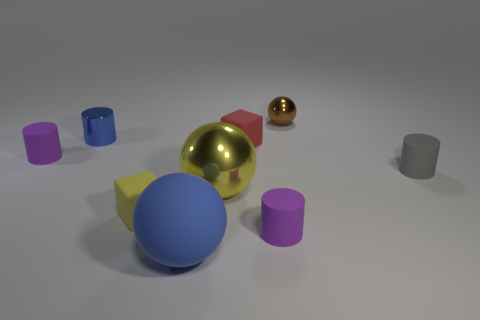Add 1 gray cylinders. How many objects exist? 10 Subtract all tiny gray matte cylinders. How many cylinders are left? 3 Subtract all cylinders. How many objects are left? 5 Subtract 1 spheres. How many spheres are left? 2 Subtract all brown cylinders. Subtract all green balls. How many cylinders are left? 4 Subtract all green cubes. How many purple balls are left? 0 Subtract all small purple rubber objects. Subtract all small red things. How many objects are left? 6 Add 8 red things. How many red things are left? 9 Add 3 small purple cylinders. How many small purple cylinders exist? 5 Subtract all red blocks. How many blocks are left? 1 